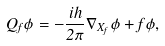Convert formula to latex. <formula><loc_0><loc_0><loc_500><loc_500>Q _ { f } \phi = - \frac { i h } { 2 \pi } \nabla _ { X _ { f } } \phi + f \phi ,</formula> 